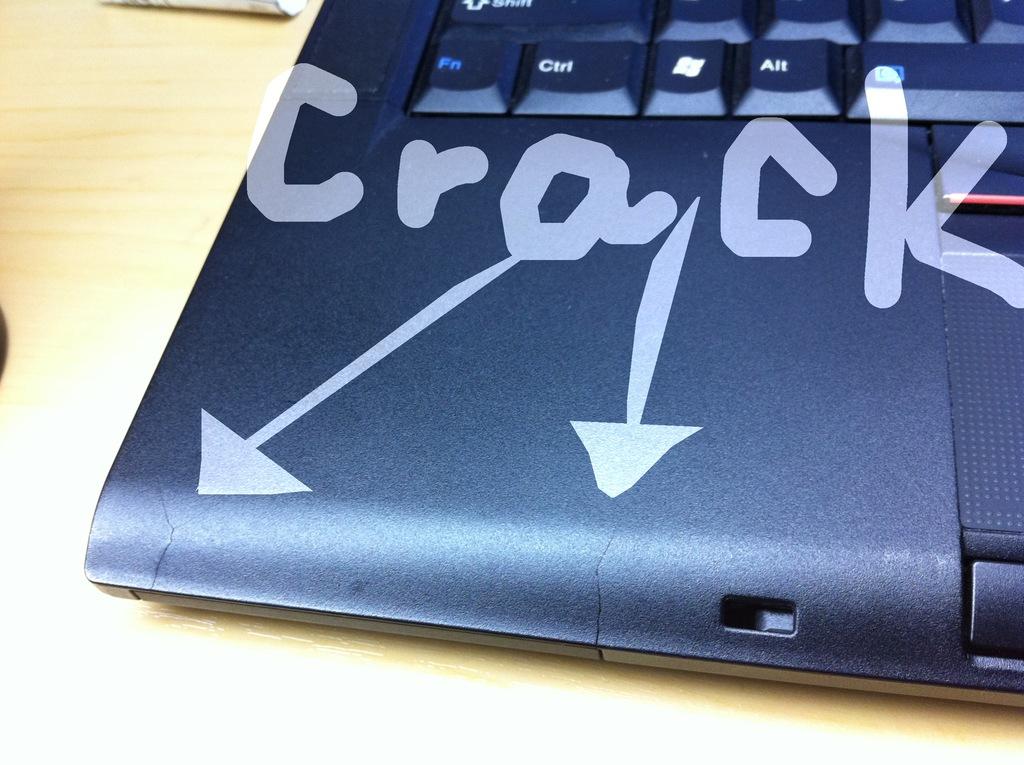What key can be seen to the left of the windows key?
Offer a terse response. Ctrl. 